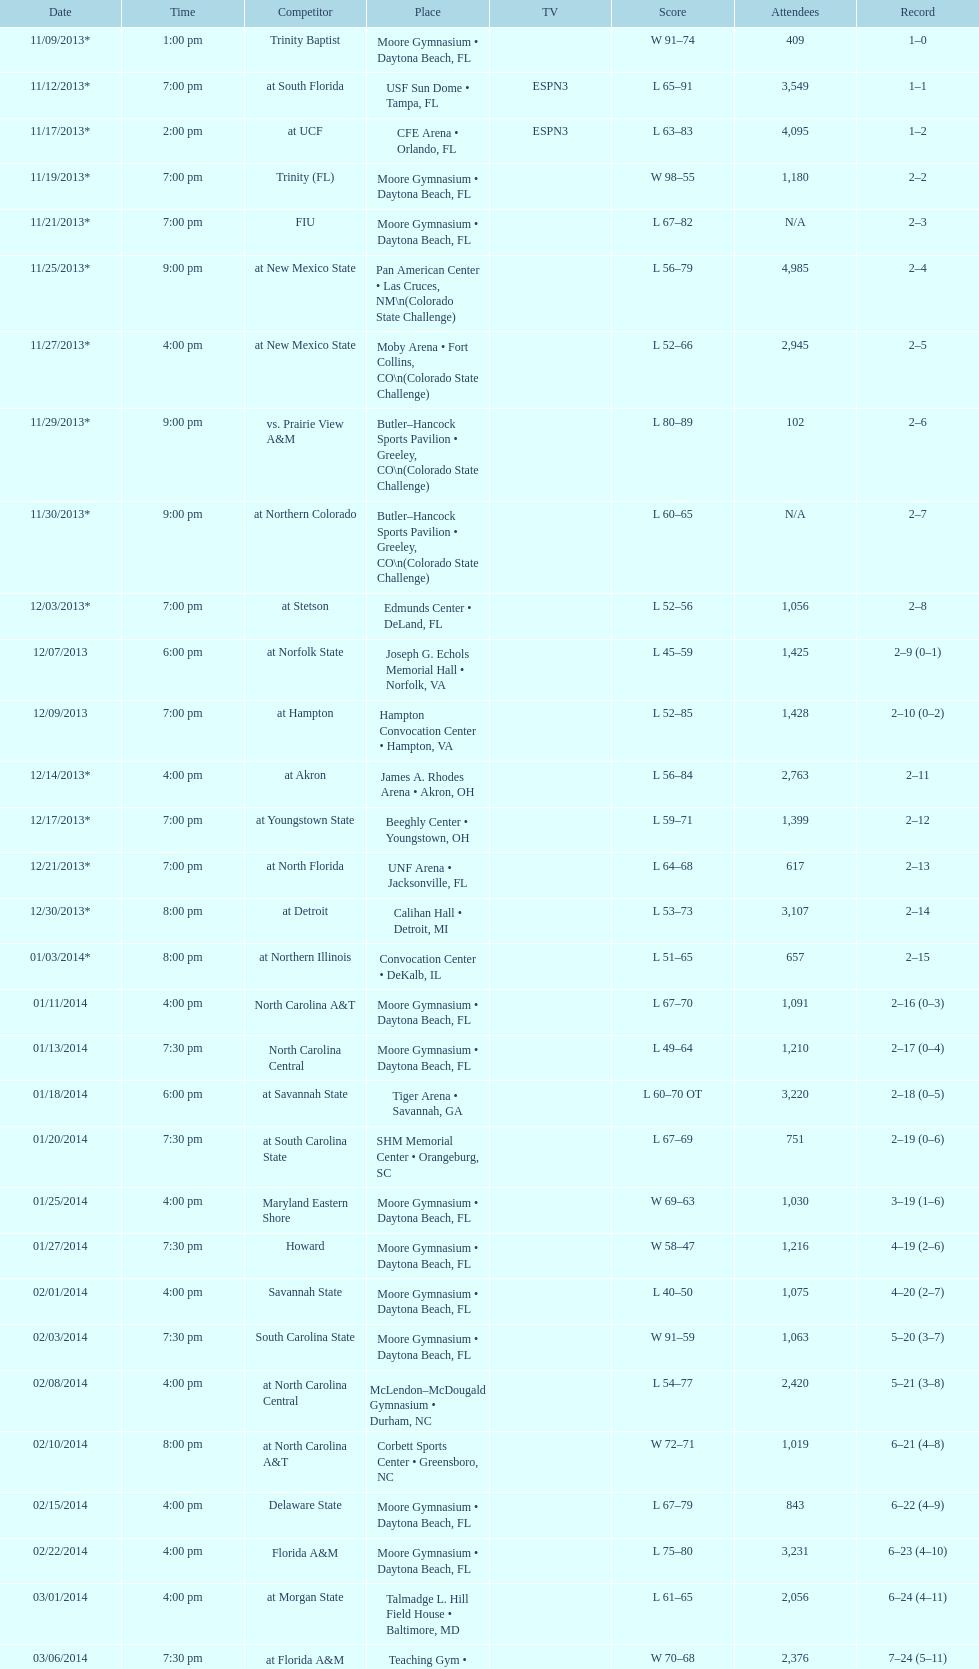How much larger was the attendance on 11/25/2013 than 12/21/2013? 4368. 